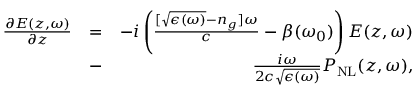<formula> <loc_0><loc_0><loc_500><loc_500>\begin{array} { r l r } { \frac { \partial E ( z , \omega ) } { \partial z } } & { = } & { - i \left ( \frac { [ \sqrt { \epsilon ( \omega ) } - n _ { g } ] \omega } { c } - \beta ( \omega _ { 0 } ) \right ) E ( z , \omega ) } \\ & { - } & { \frac { i \omega } { 2 c \sqrt { \epsilon ( \omega ) } } P _ { N L } ( z , \omega ) , } \end{array}</formula> 